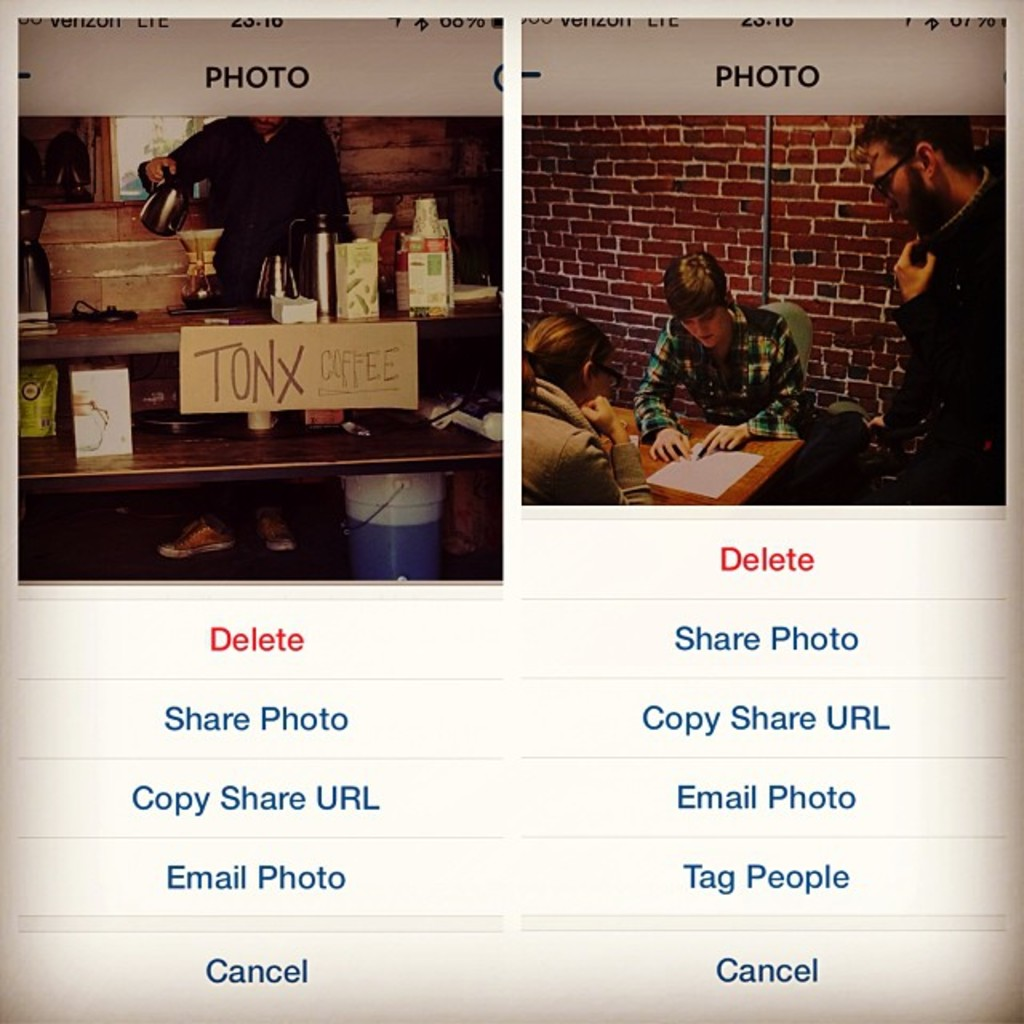What might the conversation be about in the right photo? Given the setting and the body language of the individuals, the conversation could be related to collaboration on a project or planning an event. The presence of notebooks and intense engagement suggest they are discussing topics that require attention to detail and careful consideration, possibly related to their personal, educational, or professional interests. 